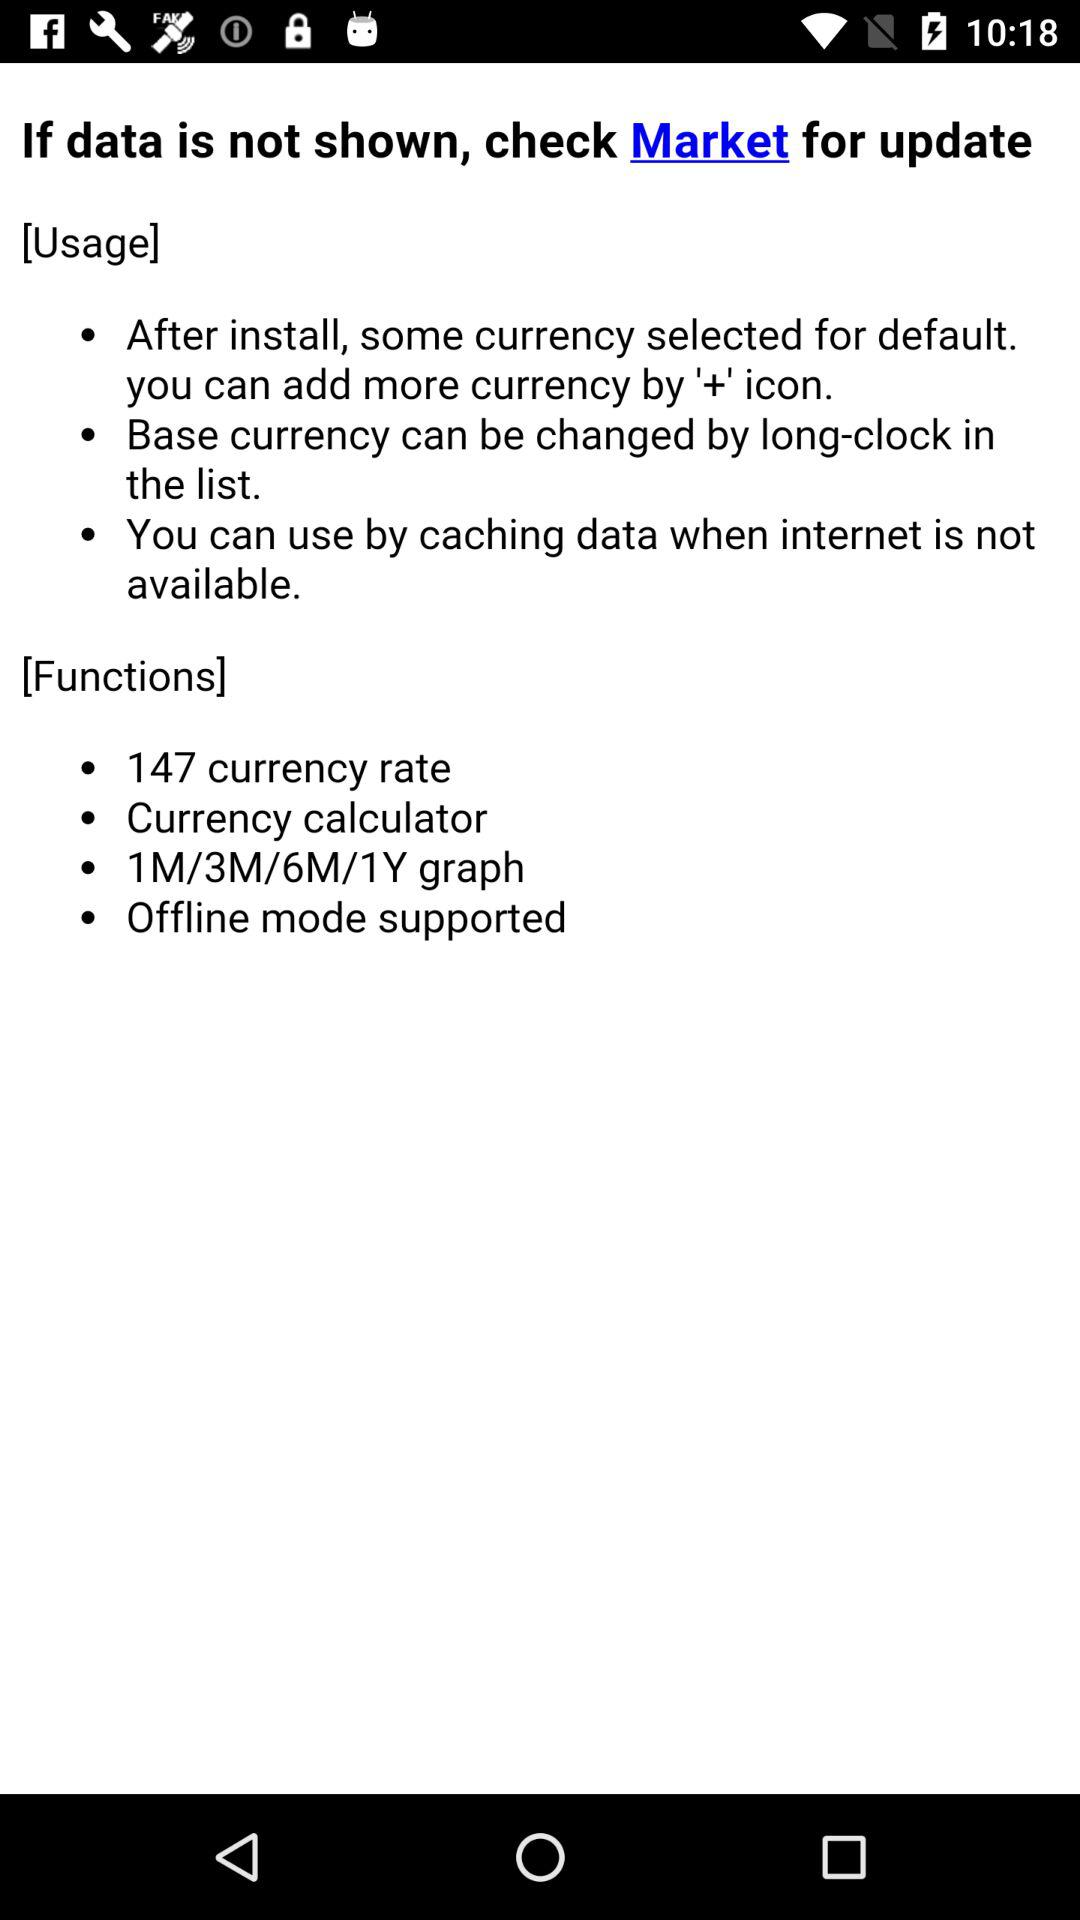How many functions does the app have?
Answer the question using a single word or phrase. 4 